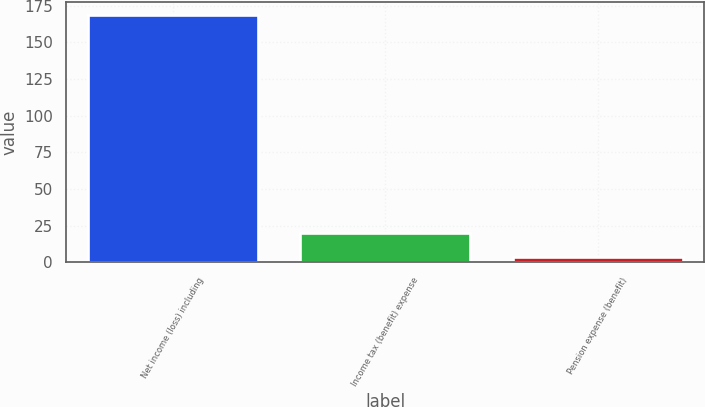Convert chart to OTSL. <chart><loc_0><loc_0><loc_500><loc_500><bar_chart><fcel>Net income (loss) including<fcel>Income tax (benefit) expense<fcel>Pension expense (benefit)<nl><fcel>168.9<fcel>20.31<fcel>3.8<nl></chart> 